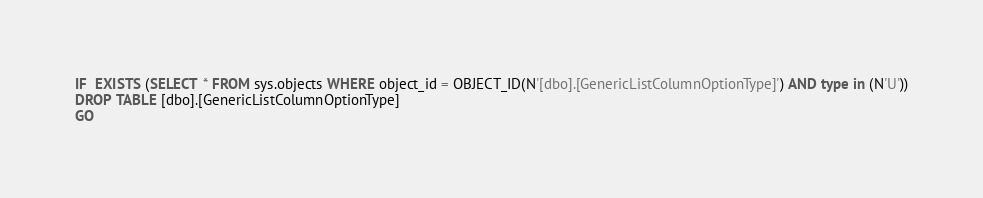<code> <loc_0><loc_0><loc_500><loc_500><_SQL_>IF  EXISTS (SELECT * FROM sys.objects WHERE object_id = OBJECT_ID(N'[dbo].[GenericListColumnOptionType]') AND type in (N'U'))
DROP TABLE [dbo].[GenericListColumnOptionType]
GO
</code> 